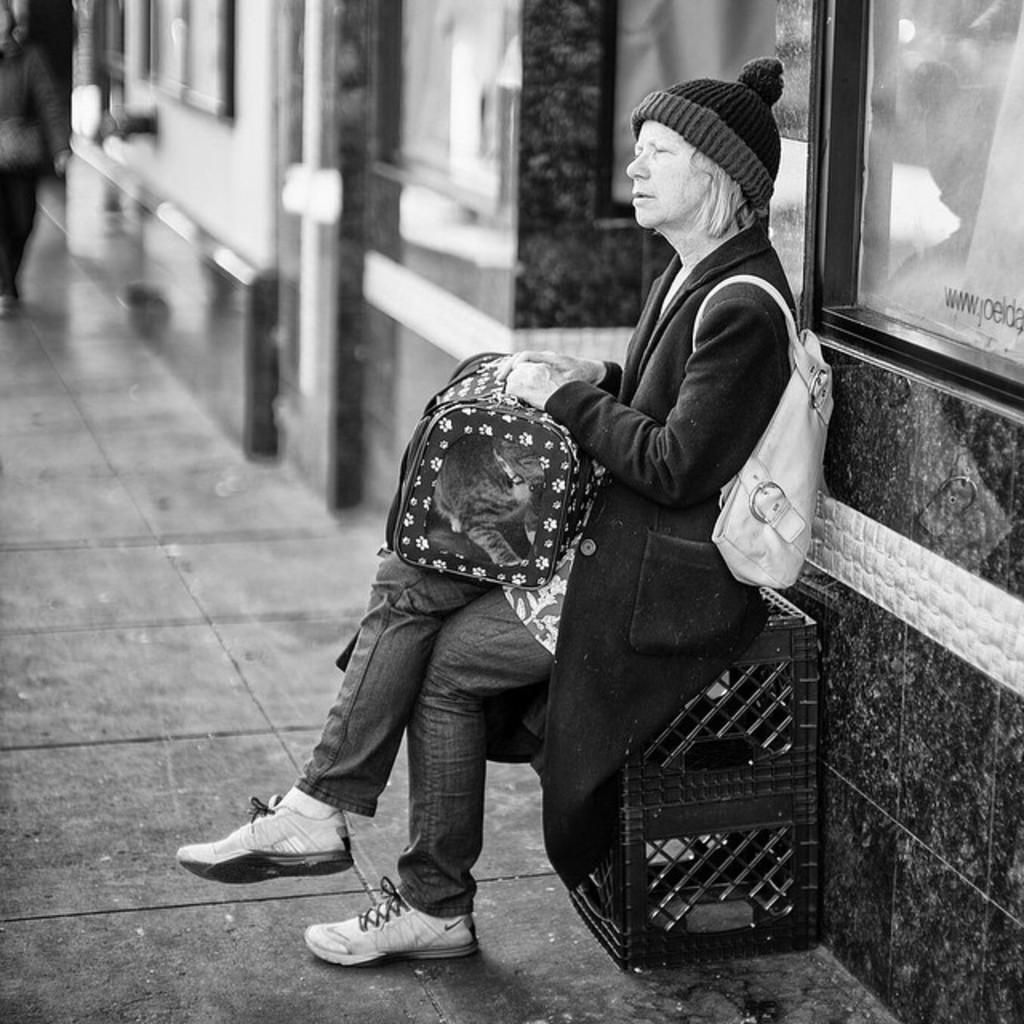What is the color scheme of the image? The image is black and white. Who is present in the image? There is a woman in the image. What is the woman wearing? The woman is wearing a bag. What is the woman doing in the image? The woman is sitting on an object. What is the object on? The object is on a surface. What can be seen in the background of the image? There is a building in the background of the image. What type of flower is the woman holding in the image? There is no flower present in the image. Can you tell me the name of the woman's aunt in the image? There is no mention of an aunt or any family members in the image. 